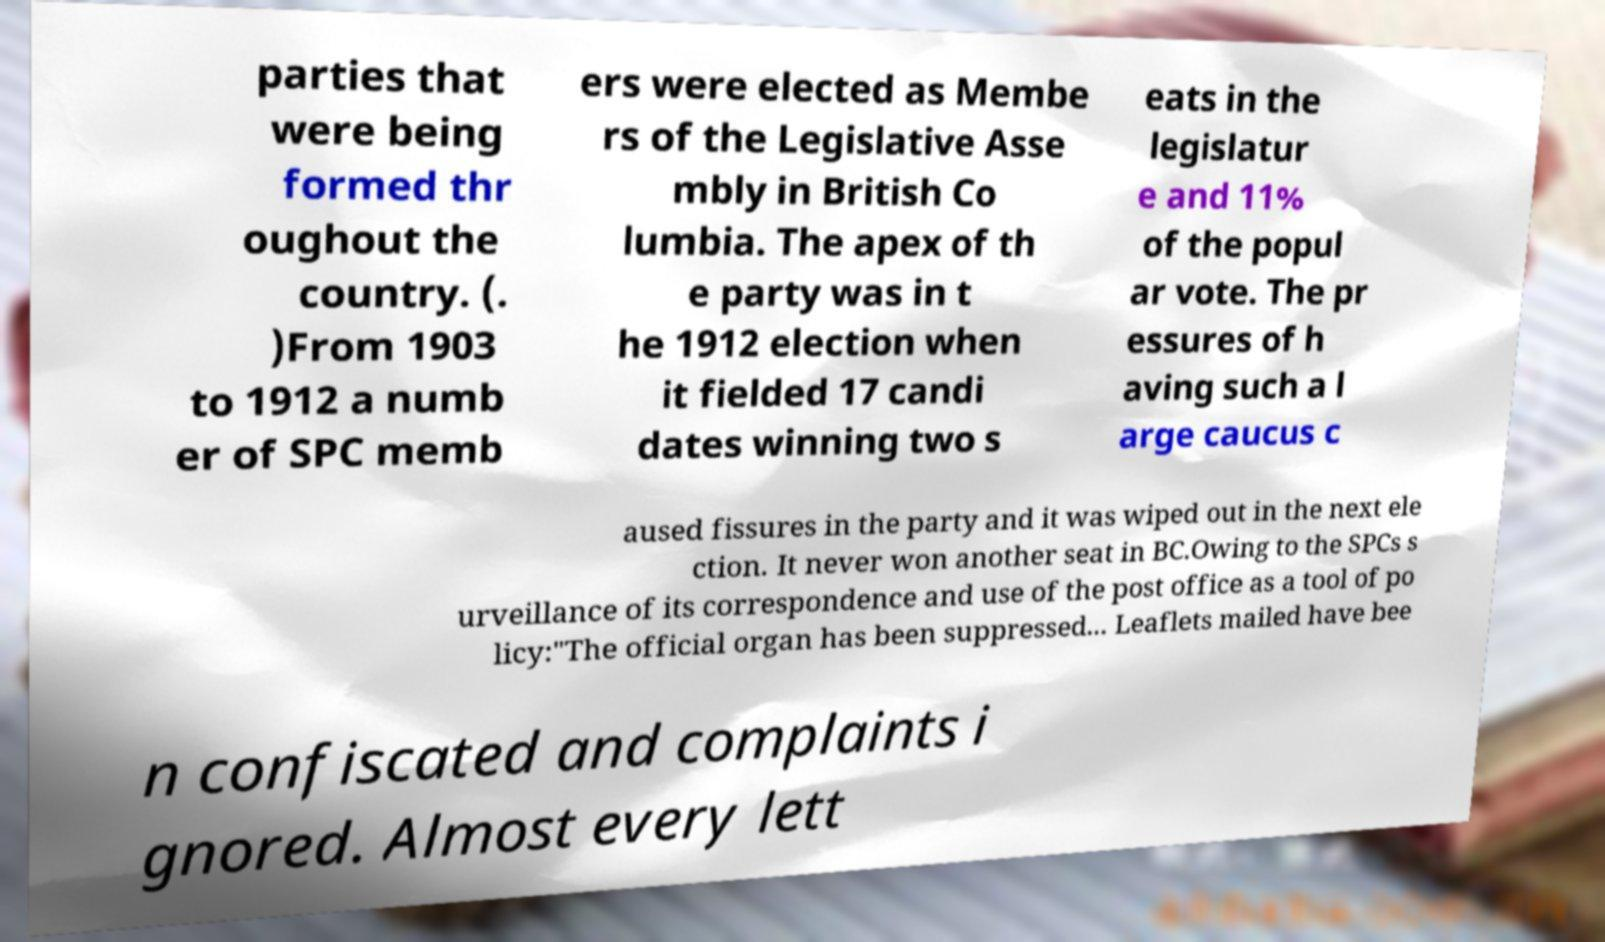I need the written content from this picture converted into text. Can you do that? parties that were being formed thr oughout the country. (. )From 1903 to 1912 a numb er of SPC memb ers were elected as Membe rs of the Legislative Asse mbly in British Co lumbia. The apex of th e party was in t he 1912 election when it fielded 17 candi dates winning two s eats in the legislatur e and 11% of the popul ar vote. The pr essures of h aving such a l arge caucus c aused fissures in the party and it was wiped out in the next ele ction. It never won another seat in BC.Owing to the SPCs s urveillance of its correspondence and use of the post office as a tool of po licy:"The official organ has been suppressed... Leaflets mailed have bee n confiscated and complaints i gnored. Almost every lett 